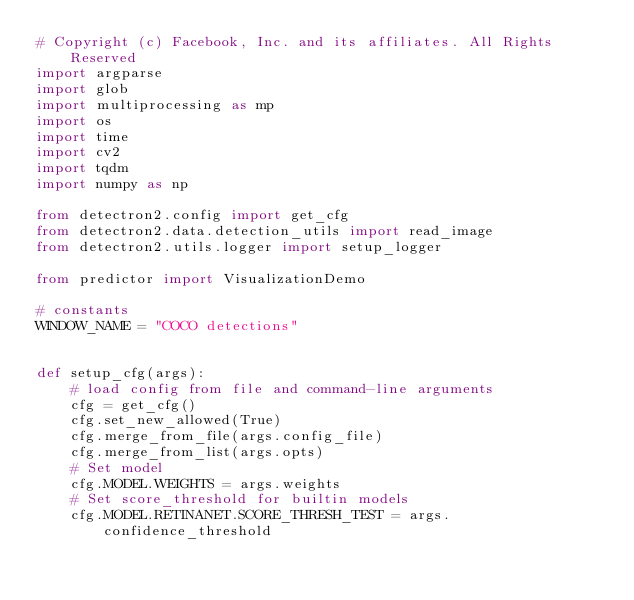Convert code to text. <code><loc_0><loc_0><loc_500><loc_500><_Python_># Copyright (c) Facebook, Inc. and its affiliates. All Rights Reserved
import argparse
import glob
import multiprocessing as mp
import os
import time
import cv2
import tqdm
import numpy as np

from detectron2.config import get_cfg
from detectron2.data.detection_utils import read_image
from detectron2.utils.logger import setup_logger

from predictor import VisualizationDemo

# constants
WINDOW_NAME = "COCO detections"


def setup_cfg(args):
    # load config from file and command-line arguments
    cfg = get_cfg()
    cfg.set_new_allowed(True)
    cfg.merge_from_file(args.config_file)
    cfg.merge_from_list(args.opts)
    # Set model
    cfg.MODEL.WEIGHTS = args.weights
    # Set score_threshold for builtin models
    cfg.MODEL.RETINANET.SCORE_THRESH_TEST = args.confidence_threshold</code> 